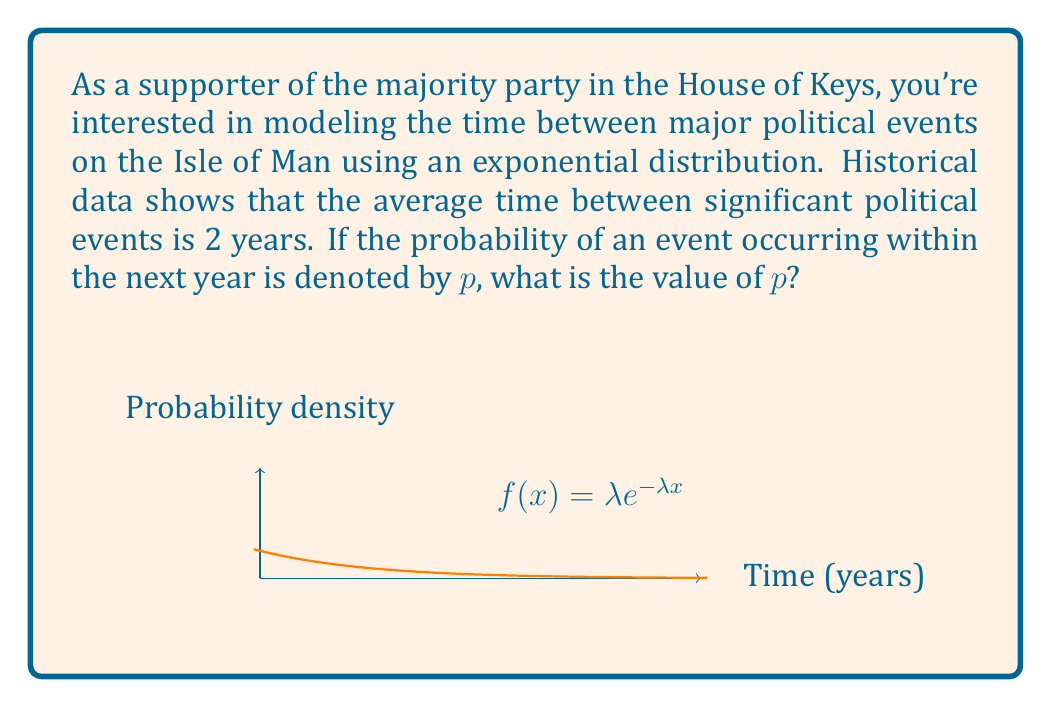What is the answer to this math problem? Let's approach this step-by-step:

1) The exponential distribution is characterized by its rate parameter $\lambda$, which is the inverse of the mean time between events. Given that the average time between events is 2 years:

   $\lambda = \frac{1}{\text{mean}} = \frac{1}{2} = 0.5$ per year

2) The cumulative distribution function (CDF) of an exponential distribution is:

   $F(x) = 1 - e^{-\lambda x}$

3) We want to find the probability of an event occurring within 1 year, so we need to calculate $F(1)$:

   $p = F(1) = 1 - e^{-\lambda \cdot 1}$

4) Substituting $\lambda = 0.5$:

   $p = 1 - e^{-0.5 \cdot 1} = 1 - e^{-0.5}$

5) Calculate the value:

   $p = 1 - e^{-0.5} \approx 0.3935$

Therefore, the probability of a major political event occurring within the next year is approximately 0.3935 or 39.35%.
Answer: $p \approx 0.3935$ 